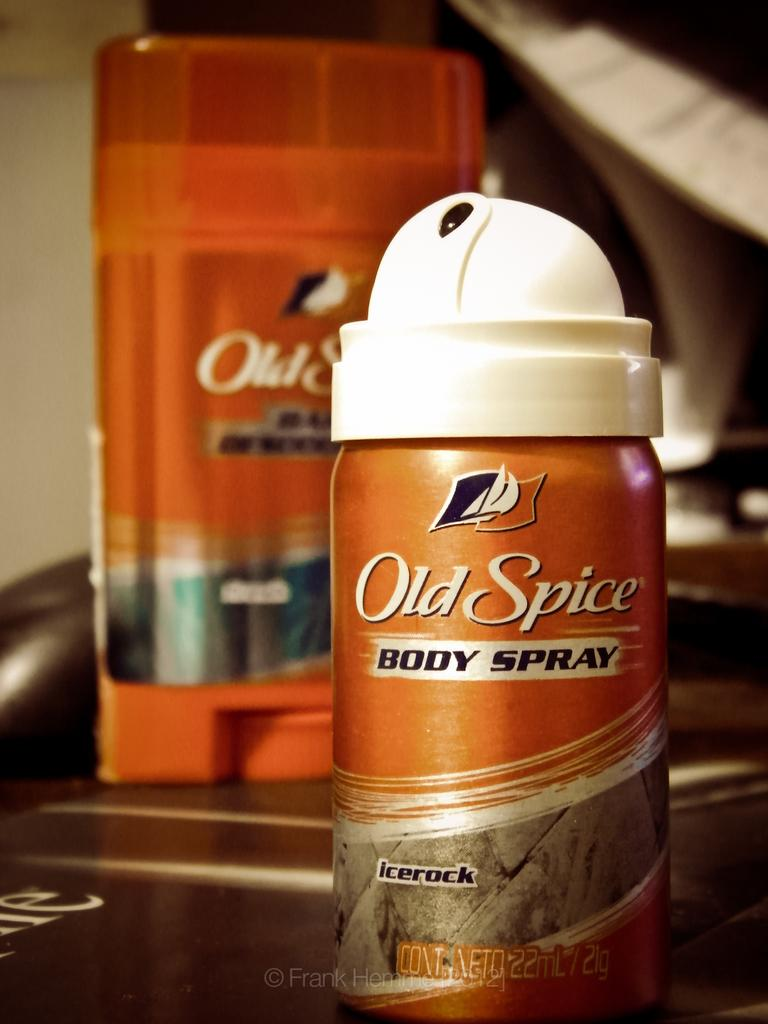<image>
Share a concise interpretation of the image provided. An Old Spice body spray and deodorant behind it. 